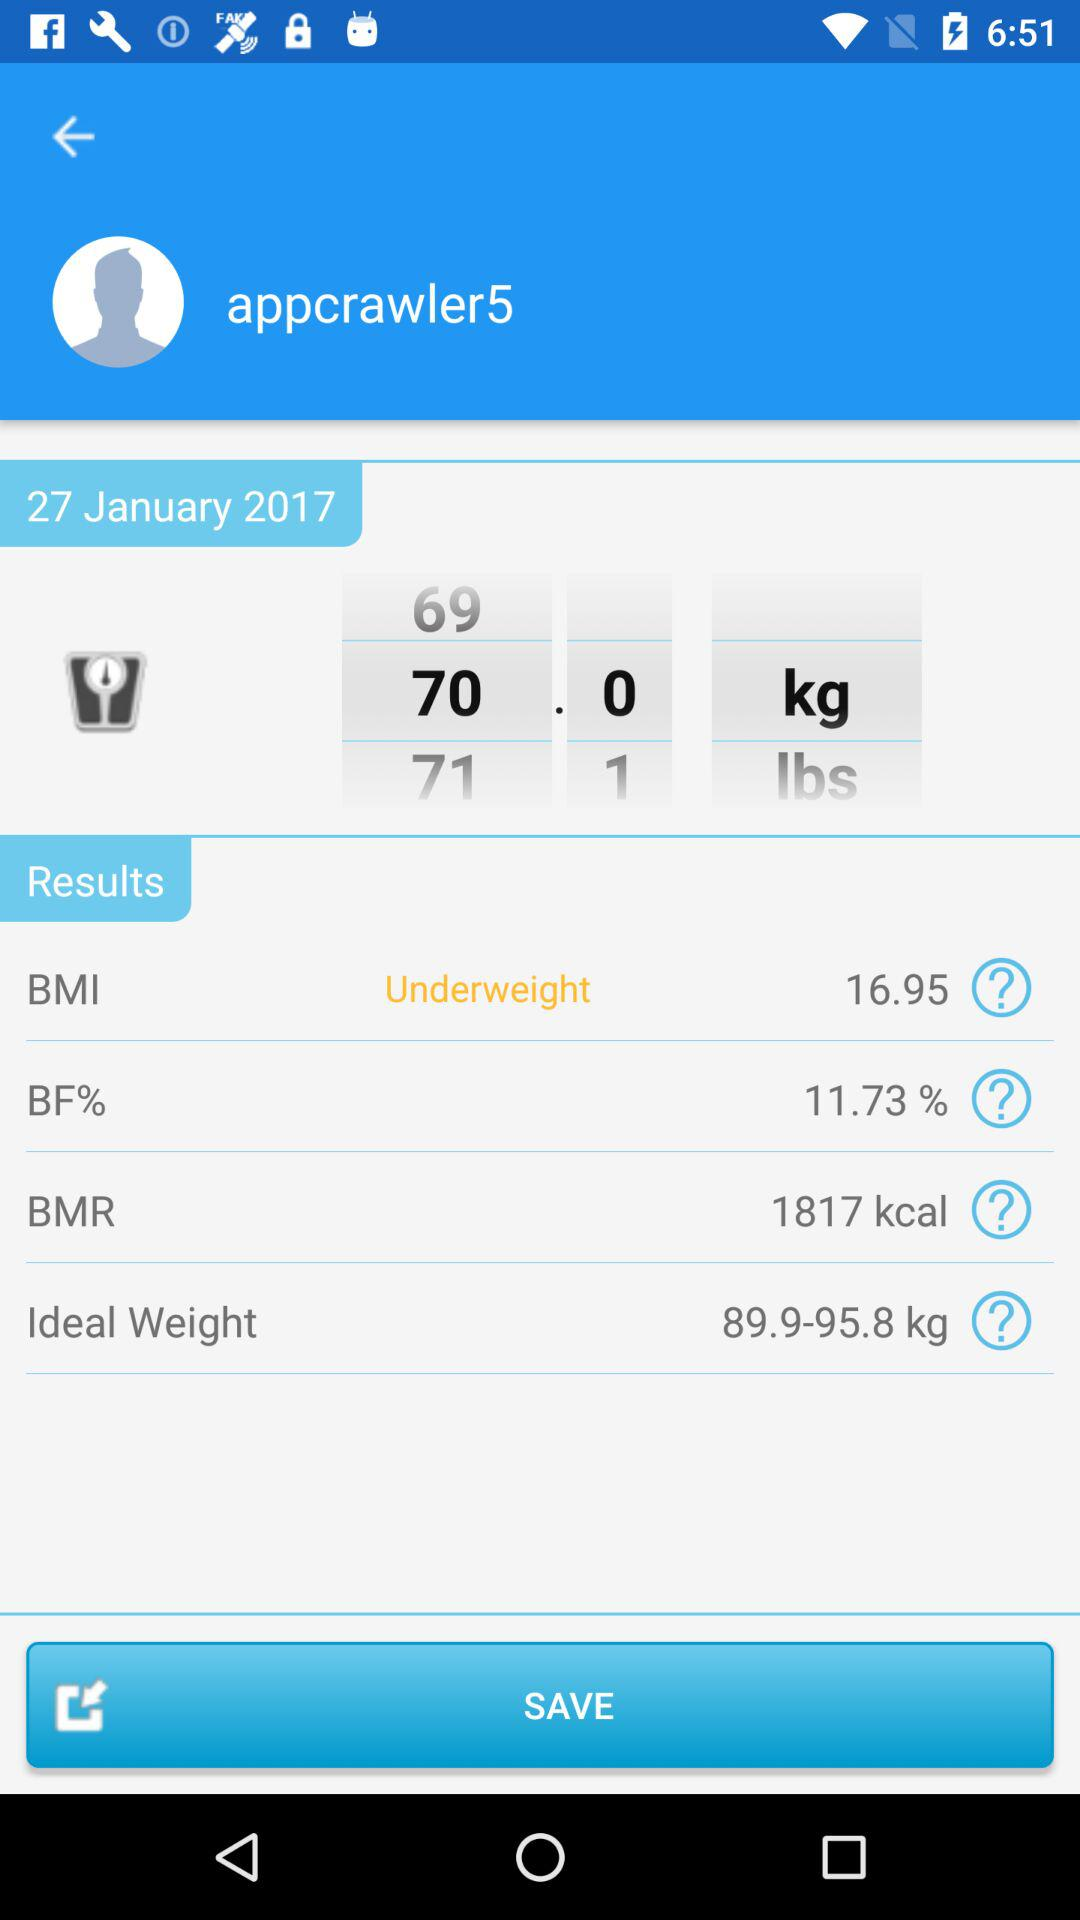What is the ideal weight range? The ideal weight range is from 89.9 to 95.8 kg. 